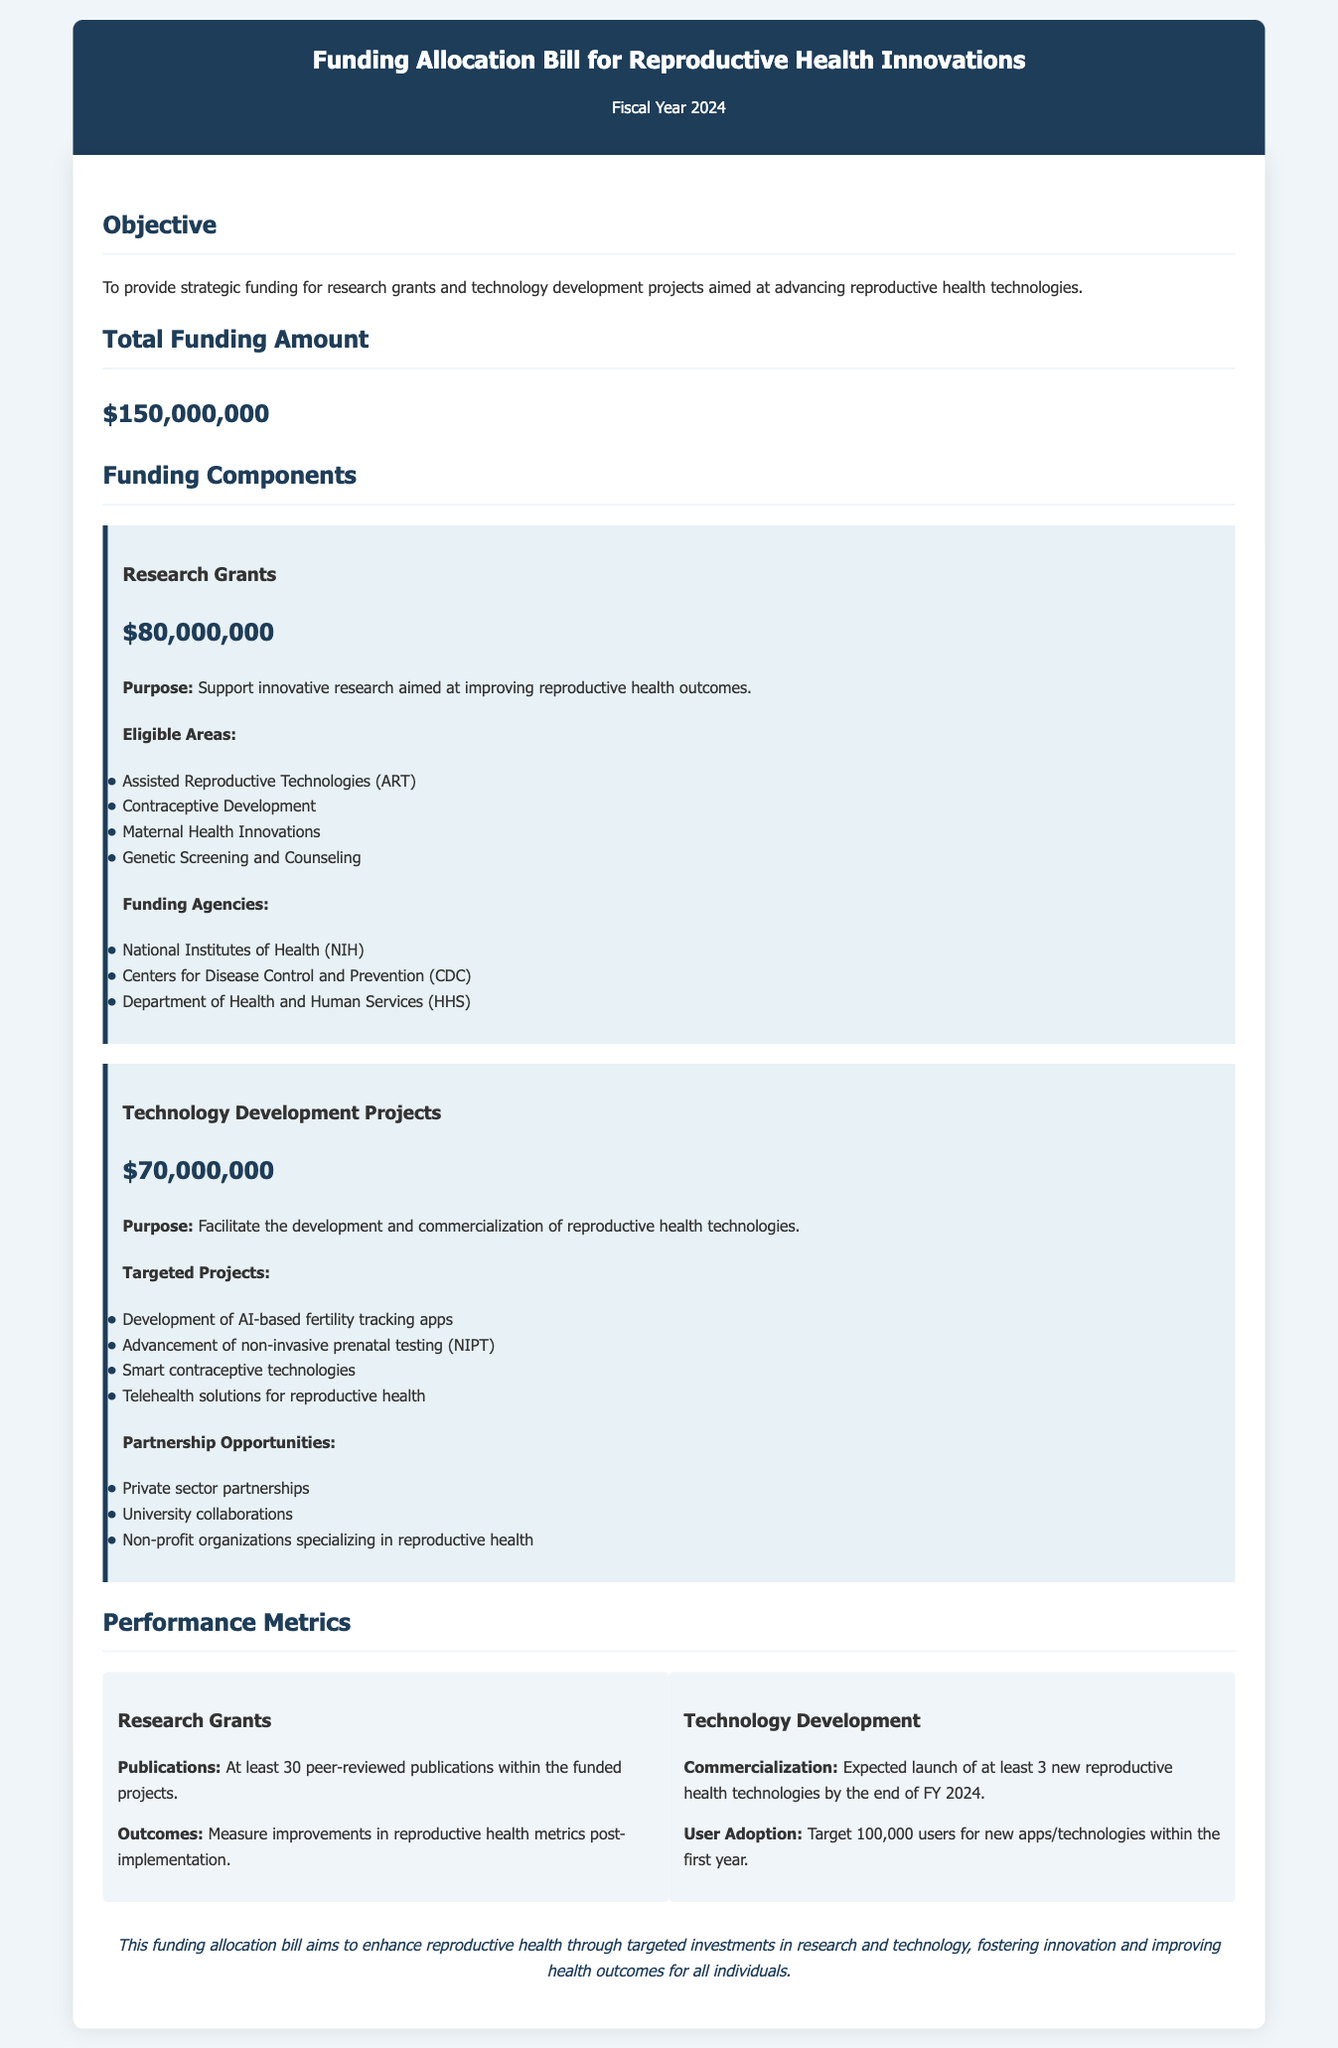What is the total funding amount? The total funding amount is stated clearly in the document as part of the funding allocation bill.
Answer: $150,000,000 What is the allocation for research grants? The document specifies the amount allocated for research grants under the funding components section.
Answer: $80,000,000 Which agency is listed for research grants? The document provides a list of funding agencies that will support research grants.
Answer: National Institutes of Health (NIH) What is the purpose of technology development projects? The purpose is described in the technology development projects section, indicating the focus of these allocations.
Answer: Facilitate the development and commercialization of reproductive health technologies How many peer-reviewed publications are expected from research grants? The performance metrics section states the expected number of publications resulting from the funded projects.
Answer: At least 30 What type of technology is targeted for development in reproductive health? The document lists specific technologies that the funding will help advance.
Answer: AI-based fertility tracking apps What is the commercialization goal for technology development by the end of FY 2024? The performance metrics provide the expected outcome for new technology launches within the specified timeframe.
Answer: At least 3 Which collaborative opportunities are encouraged under technology projects? The document lists various partnership opportunities for technology development projects that involve different sectors.
Answer: Private sector partnerships 